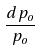<formula> <loc_0><loc_0><loc_500><loc_500>\frac { d p _ { o } } { p _ { o } }</formula> 